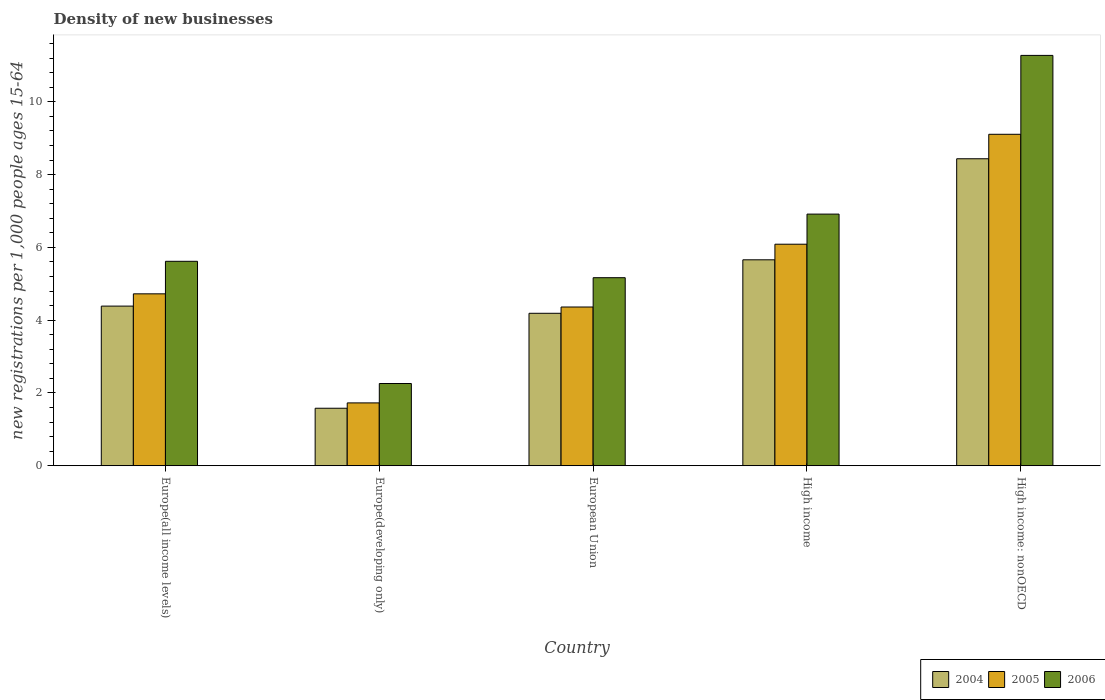How many different coloured bars are there?
Give a very brief answer. 3. Are the number of bars per tick equal to the number of legend labels?
Your response must be concise. Yes. What is the label of the 5th group of bars from the left?
Offer a very short reply. High income: nonOECD. In how many cases, is the number of bars for a given country not equal to the number of legend labels?
Provide a succinct answer. 0. What is the number of new registrations in 2006 in Europe(all income levels)?
Offer a terse response. 5.62. Across all countries, what is the maximum number of new registrations in 2006?
Offer a terse response. 11.28. Across all countries, what is the minimum number of new registrations in 2005?
Offer a terse response. 1.73. In which country was the number of new registrations in 2006 maximum?
Keep it short and to the point. High income: nonOECD. In which country was the number of new registrations in 2005 minimum?
Provide a succinct answer. Europe(developing only). What is the total number of new registrations in 2004 in the graph?
Your answer should be compact. 24.25. What is the difference between the number of new registrations in 2006 in Europe(all income levels) and that in High income: nonOECD?
Offer a terse response. -5.66. What is the difference between the number of new registrations in 2004 in High income: nonOECD and the number of new registrations in 2005 in European Union?
Keep it short and to the point. 4.07. What is the average number of new registrations in 2006 per country?
Offer a very short reply. 6.25. What is the difference between the number of new registrations of/in 2005 and number of new registrations of/in 2004 in European Union?
Your answer should be compact. 0.17. In how many countries, is the number of new registrations in 2005 greater than 3.2?
Provide a short and direct response. 4. What is the ratio of the number of new registrations in 2005 in Europe(all income levels) to that in High income?
Your answer should be very brief. 0.78. Is the number of new registrations in 2004 in European Union less than that in High income?
Provide a succinct answer. Yes. Is the difference between the number of new registrations in 2005 in Europe(all income levels) and Europe(developing only) greater than the difference between the number of new registrations in 2004 in Europe(all income levels) and Europe(developing only)?
Provide a short and direct response. Yes. What is the difference between the highest and the second highest number of new registrations in 2006?
Your answer should be compact. 5.66. What is the difference between the highest and the lowest number of new registrations in 2006?
Offer a terse response. 9.02. Is the sum of the number of new registrations in 2004 in Europe(developing only) and European Union greater than the maximum number of new registrations in 2005 across all countries?
Offer a very short reply. No. What does the 3rd bar from the left in High income represents?
Your answer should be compact. 2006. Is it the case that in every country, the sum of the number of new registrations in 2006 and number of new registrations in 2005 is greater than the number of new registrations in 2004?
Provide a short and direct response. Yes. How many bars are there?
Provide a succinct answer. 15. Are all the bars in the graph horizontal?
Your response must be concise. No. How many countries are there in the graph?
Make the answer very short. 5. Are the values on the major ticks of Y-axis written in scientific E-notation?
Give a very brief answer. No. Where does the legend appear in the graph?
Make the answer very short. Bottom right. How are the legend labels stacked?
Your response must be concise. Horizontal. What is the title of the graph?
Keep it short and to the point. Density of new businesses. What is the label or title of the Y-axis?
Your response must be concise. New registrations per 1,0 people ages 15-64. What is the new registrations per 1,000 people ages 15-64 in 2004 in Europe(all income levels)?
Offer a terse response. 4.39. What is the new registrations per 1,000 people ages 15-64 in 2005 in Europe(all income levels)?
Your answer should be very brief. 4.72. What is the new registrations per 1,000 people ages 15-64 of 2006 in Europe(all income levels)?
Make the answer very short. 5.62. What is the new registrations per 1,000 people ages 15-64 in 2004 in Europe(developing only)?
Provide a succinct answer. 1.58. What is the new registrations per 1,000 people ages 15-64 of 2005 in Europe(developing only)?
Ensure brevity in your answer.  1.73. What is the new registrations per 1,000 people ages 15-64 of 2006 in Europe(developing only)?
Offer a very short reply. 2.26. What is the new registrations per 1,000 people ages 15-64 in 2004 in European Union?
Keep it short and to the point. 4.19. What is the new registrations per 1,000 people ages 15-64 in 2005 in European Union?
Ensure brevity in your answer.  4.36. What is the new registrations per 1,000 people ages 15-64 in 2006 in European Union?
Give a very brief answer. 5.17. What is the new registrations per 1,000 people ages 15-64 in 2004 in High income?
Your answer should be compact. 5.66. What is the new registrations per 1,000 people ages 15-64 of 2005 in High income?
Make the answer very short. 6.09. What is the new registrations per 1,000 people ages 15-64 in 2006 in High income?
Your answer should be very brief. 6.91. What is the new registrations per 1,000 people ages 15-64 of 2004 in High income: nonOECD?
Give a very brief answer. 8.44. What is the new registrations per 1,000 people ages 15-64 of 2005 in High income: nonOECD?
Make the answer very short. 9.11. What is the new registrations per 1,000 people ages 15-64 in 2006 in High income: nonOECD?
Make the answer very short. 11.28. Across all countries, what is the maximum new registrations per 1,000 people ages 15-64 in 2004?
Provide a short and direct response. 8.44. Across all countries, what is the maximum new registrations per 1,000 people ages 15-64 in 2005?
Your response must be concise. 9.11. Across all countries, what is the maximum new registrations per 1,000 people ages 15-64 in 2006?
Offer a very short reply. 11.28. Across all countries, what is the minimum new registrations per 1,000 people ages 15-64 in 2004?
Ensure brevity in your answer.  1.58. Across all countries, what is the minimum new registrations per 1,000 people ages 15-64 in 2005?
Provide a succinct answer. 1.73. Across all countries, what is the minimum new registrations per 1,000 people ages 15-64 of 2006?
Give a very brief answer. 2.26. What is the total new registrations per 1,000 people ages 15-64 of 2004 in the graph?
Keep it short and to the point. 24.25. What is the total new registrations per 1,000 people ages 15-64 of 2005 in the graph?
Make the answer very short. 26.01. What is the total new registrations per 1,000 people ages 15-64 of 2006 in the graph?
Give a very brief answer. 31.24. What is the difference between the new registrations per 1,000 people ages 15-64 of 2004 in Europe(all income levels) and that in Europe(developing only)?
Provide a succinct answer. 2.81. What is the difference between the new registrations per 1,000 people ages 15-64 in 2005 in Europe(all income levels) and that in Europe(developing only)?
Make the answer very short. 3. What is the difference between the new registrations per 1,000 people ages 15-64 of 2006 in Europe(all income levels) and that in Europe(developing only)?
Keep it short and to the point. 3.36. What is the difference between the new registrations per 1,000 people ages 15-64 in 2004 in Europe(all income levels) and that in European Union?
Make the answer very short. 0.2. What is the difference between the new registrations per 1,000 people ages 15-64 of 2005 in Europe(all income levels) and that in European Union?
Provide a short and direct response. 0.36. What is the difference between the new registrations per 1,000 people ages 15-64 in 2006 in Europe(all income levels) and that in European Union?
Keep it short and to the point. 0.45. What is the difference between the new registrations per 1,000 people ages 15-64 of 2004 in Europe(all income levels) and that in High income?
Provide a short and direct response. -1.27. What is the difference between the new registrations per 1,000 people ages 15-64 of 2005 in Europe(all income levels) and that in High income?
Provide a succinct answer. -1.36. What is the difference between the new registrations per 1,000 people ages 15-64 of 2006 in Europe(all income levels) and that in High income?
Offer a terse response. -1.3. What is the difference between the new registrations per 1,000 people ages 15-64 of 2004 in Europe(all income levels) and that in High income: nonOECD?
Offer a very short reply. -4.05. What is the difference between the new registrations per 1,000 people ages 15-64 in 2005 in Europe(all income levels) and that in High income: nonOECD?
Offer a very short reply. -4.38. What is the difference between the new registrations per 1,000 people ages 15-64 in 2006 in Europe(all income levels) and that in High income: nonOECD?
Give a very brief answer. -5.66. What is the difference between the new registrations per 1,000 people ages 15-64 of 2004 in Europe(developing only) and that in European Union?
Your answer should be very brief. -2.61. What is the difference between the new registrations per 1,000 people ages 15-64 of 2005 in Europe(developing only) and that in European Union?
Give a very brief answer. -2.64. What is the difference between the new registrations per 1,000 people ages 15-64 in 2006 in Europe(developing only) and that in European Union?
Ensure brevity in your answer.  -2.91. What is the difference between the new registrations per 1,000 people ages 15-64 in 2004 in Europe(developing only) and that in High income?
Provide a succinct answer. -4.08. What is the difference between the new registrations per 1,000 people ages 15-64 in 2005 in Europe(developing only) and that in High income?
Offer a terse response. -4.36. What is the difference between the new registrations per 1,000 people ages 15-64 in 2006 in Europe(developing only) and that in High income?
Your response must be concise. -4.66. What is the difference between the new registrations per 1,000 people ages 15-64 of 2004 in Europe(developing only) and that in High income: nonOECD?
Make the answer very short. -6.86. What is the difference between the new registrations per 1,000 people ages 15-64 of 2005 in Europe(developing only) and that in High income: nonOECD?
Your answer should be very brief. -7.38. What is the difference between the new registrations per 1,000 people ages 15-64 of 2006 in Europe(developing only) and that in High income: nonOECD?
Offer a terse response. -9.02. What is the difference between the new registrations per 1,000 people ages 15-64 in 2004 in European Union and that in High income?
Offer a very short reply. -1.47. What is the difference between the new registrations per 1,000 people ages 15-64 in 2005 in European Union and that in High income?
Provide a short and direct response. -1.73. What is the difference between the new registrations per 1,000 people ages 15-64 in 2006 in European Union and that in High income?
Your answer should be very brief. -1.75. What is the difference between the new registrations per 1,000 people ages 15-64 in 2004 in European Union and that in High income: nonOECD?
Keep it short and to the point. -4.25. What is the difference between the new registrations per 1,000 people ages 15-64 of 2005 in European Union and that in High income: nonOECD?
Give a very brief answer. -4.75. What is the difference between the new registrations per 1,000 people ages 15-64 in 2006 in European Union and that in High income: nonOECD?
Ensure brevity in your answer.  -6.11. What is the difference between the new registrations per 1,000 people ages 15-64 of 2004 in High income and that in High income: nonOECD?
Provide a short and direct response. -2.78. What is the difference between the new registrations per 1,000 people ages 15-64 in 2005 in High income and that in High income: nonOECD?
Your answer should be very brief. -3.02. What is the difference between the new registrations per 1,000 people ages 15-64 in 2006 in High income and that in High income: nonOECD?
Offer a terse response. -4.36. What is the difference between the new registrations per 1,000 people ages 15-64 of 2004 in Europe(all income levels) and the new registrations per 1,000 people ages 15-64 of 2005 in Europe(developing only)?
Your answer should be very brief. 2.66. What is the difference between the new registrations per 1,000 people ages 15-64 of 2004 in Europe(all income levels) and the new registrations per 1,000 people ages 15-64 of 2006 in Europe(developing only)?
Provide a short and direct response. 2.13. What is the difference between the new registrations per 1,000 people ages 15-64 in 2005 in Europe(all income levels) and the new registrations per 1,000 people ages 15-64 in 2006 in Europe(developing only)?
Give a very brief answer. 2.46. What is the difference between the new registrations per 1,000 people ages 15-64 in 2004 in Europe(all income levels) and the new registrations per 1,000 people ages 15-64 in 2005 in European Union?
Provide a succinct answer. 0.02. What is the difference between the new registrations per 1,000 people ages 15-64 in 2004 in Europe(all income levels) and the new registrations per 1,000 people ages 15-64 in 2006 in European Union?
Provide a succinct answer. -0.78. What is the difference between the new registrations per 1,000 people ages 15-64 in 2005 in Europe(all income levels) and the new registrations per 1,000 people ages 15-64 in 2006 in European Union?
Keep it short and to the point. -0.44. What is the difference between the new registrations per 1,000 people ages 15-64 in 2004 in Europe(all income levels) and the new registrations per 1,000 people ages 15-64 in 2005 in High income?
Your response must be concise. -1.7. What is the difference between the new registrations per 1,000 people ages 15-64 in 2004 in Europe(all income levels) and the new registrations per 1,000 people ages 15-64 in 2006 in High income?
Keep it short and to the point. -2.53. What is the difference between the new registrations per 1,000 people ages 15-64 in 2005 in Europe(all income levels) and the new registrations per 1,000 people ages 15-64 in 2006 in High income?
Offer a very short reply. -2.19. What is the difference between the new registrations per 1,000 people ages 15-64 in 2004 in Europe(all income levels) and the new registrations per 1,000 people ages 15-64 in 2005 in High income: nonOECD?
Offer a very short reply. -4.72. What is the difference between the new registrations per 1,000 people ages 15-64 in 2004 in Europe(all income levels) and the new registrations per 1,000 people ages 15-64 in 2006 in High income: nonOECD?
Keep it short and to the point. -6.89. What is the difference between the new registrations per 1,000 people ages 15-64 in 2005 in Europe(all income levels) and the new registrations per 1,000 people ages 15-64 in 2006 in High income: nonOECD?
Your answer should be very brief. -6.55. What is the difference between the new registrations per 1,000 people ages 15-64 of 2004 in Europe(developing only) and the new registrations per 1,000 people ages 15-64 of 2005 in European Union?
Offer a terse response. -2.78. What is the difference between the new registrations per 1,000 people ages 15-64 in 2004 in Europe(developing only) and the new registrations per 1,000 people ages 15-64 in 2006 in European Union?
Provide a succinct answer. -3.59. What is the difference between the new registrations per 1,000 people ages 15-64 of 2005 in Europe(developing only) and the new registrations per 1,000 people ages 15-64 of 2006 in European Union?
Provide a short and direct response. -3.44. What is the difference between the new registrations per 1,000 people ages 15-64 of 2004 in Europe(developing only) and the new registrations per 1,000 people ages 15-64 of 2005 in High income?
Ensure brevity in your answer.  -4.51. What is the difference between the new registrations per 1,000 people ages 15-64 in 2004 in Europe(developing only) and the new registrations per 1,000 people ages 15-64 in 2006 in High income?
Offer a terse response. -5.33. What is the difference between the new registrations per 1,000 people ages 15-64 of 2005 in Europe(developing only) and the new registrations per 1,000 people ages 15-64 of 2006 in High income?
Provide a short and direct response. -5.19. What is the difference between the new registrations per 1,000 people ages 15-64 in 2004 in Europe(developing only) and the new registrations per 1,000 people ages 15-64 in 2005 in High income: nonOECD?
Provide a succinct answer. -7.53. What is the difference between the new registrations per 1,000 people ages 15-64 of 2004 in Europe(developing only) and the new registrations per 1,000 people ages 15-64 of 2006 in High income: nonOECD?
Ensure brevity in your answer.  -9.7. What is the difference between the new registrations per 1,000 people ages 15-64 of 2005 in Europe(developing only) and the new registrations per 1,000 people ages 15-64 of 2006 in High income: nonOECD?
Your answer should be very brief. -9.55. What is the difference between the new registrations per 1,000 people ages 15-64 of 2004 in European Union and the new registrations per 1,000 people ages 15-64 of 2005 in High income?
Your answer should be compact. -1.9. What is the difference between the new registrations per 1,000 people ages 15-64 in 2004 in European Union and the new registrations per 1,000 people ages 15-64 in 2006 in High income?
Offer a very short reply. -2.73. What is the difference between the new registrations per 1,000 people ages 15-64 in 2005 in European Union and the new registrations per 1,000 people ages 15-64 in 2006 in High income?
Offer a terse response. -2.55. What is the difference between the new registrations per 1,000 people ages 15-64 in 2004 in European Union and the new registrations per 1,000 people ages 15-64 in 2005 in High income: nonOECD?
Your answer should be very brief. -4.92. What is the difference between the new registrations per 1,000 people ages 15-64 of 2004 in European Union and the new registrations per 1,000 people ages 15-64 of 2006 in High income: nonOECD?
Make the answer very short. -7.09. What is the difference between the new registrations per 1,000 people ages 15-64 of 2005 in European Union and the new registrations per 1,000 people ages 15-64 of 2006 in High income: nonOECD?
Make the answer very short. -6.91. What is the difference between the new registrations per 1,000 people ages 15-64 in 2004 in High income and the new registrations per 1,000 people ages 15-64 in 2005 in High income: nonOECD?
Offer a terse response. -3.45. What is the difference between the new registrations per 1,000 people ages 15-64 in 2004 in High income and the new registrations per 1,000 people ages 15-64 in 2006 in High income: nonOECD?
Provide a succinct answer. -5.62. What is the difference between the new registrations per 1,000 people ages 15-64 of 2005 in High income and the new registrations per 1,000 people ages 15-64 of 2006 in High income: nonOECD?
Your response must be concise. -5.19. What is the average new registrations per 1,000 people ages 15-64 in 2004 per country?
Keep it short and to the point. 4.85. What is the average new registrations per 1,000 people ages 15-64 of 2005 per country?
Give a very brief answer. 5.2. What is the average new registrations per 1,000 people ages 15-64 in 2006 per country?
Provide a short and direct response. 6.25. What is the difference between the new registrations per 1,000 people ages 15-64 of 2004 and new registrations per 1,000 people ages 15-64 of 2005 in Europe(all income levels)?
Your answer should be compact. -0.34. What is the difference between the new registrations per 1,000 people ages 15-64 in 2004 and new registrations per 1,000 people ages 15-64 in 2006 in Europe(all income levels)?
Offer a very short reply. -1.23. What is the difference between the new registrations per 1,000 people ages 15-64 of 2005 and new registrations per 1,000 people ages 15-64 of 2006 in Europe(all income levels)?
Your answer should be very brief. -0.89. What is the difference between the new registrations per 1,000 people ages 15-64 of 2004 and new registrations per 1,000 people ages 15-64 of 2005 in Europe(developing only)?
Your answer should be compact. -0.15. What is the difference between the new registrations per 1,000 people ages 15-64 of 2004 and new registrations per 1,000 people ages 15-64 of 2006 in Europe(developing only)?
Ensure brevity in your answer.  -0.68. What is the difference between the new registrations per 1,000 people ages 15-64 of 2005 and new registrations per 1,000 people ages 15-64 of 2006 in Europe(developing only)?
Your answer should be very brief. -0.53. What is the difference between the new registrations per 1,000 people ages 15-64 of 2004 and new registrations per 1,000 people ages 15-64 of 2005 in European Union?
Your answer should be compact. -0.17. What is the difference between the new registrations per 1,000 people ages 15-64 of 2004 and new registrations per 1,000 people ages 15-64 of 2006 in European Union?
Provide a succinct answer. -0.98. What is the difference between the new registrations per 1,000 people ages 15-64 in 2005 and new registrations per 1,000 people ages 15-64 in 2006 in European Union?
Your answer should be very brief. -0.81. What is the difference between the new registrations per 1,000 people ages 15-64 of 2004 and new registrations per 1,000 people ages 15-64 of 2005 in High income?
Provide a succinct answer. -0.43. What is the difference between the new registrations per 1,000 people ages 15-64 of 2004 and new registrations per 1,000 people ages 15-64 of 2006 in High income?
Offer a terse response. -1.26. What is the difference between the new registrations per 1,000 people ages 15-64 in 2005 and new registrations per 1,000 people ages 15-64 in 2006 in High income?
Your answer should be compact. -0.83. What is the difference between the new registrations per 1,000 people ages 15-64 of 2004 and new registrations per 1,000 people ages 15-64 of 2005 in High income: nonOECD?
Offer a very short reply. -0.67. What is the difference between the new registrations per 1,000 people ages 15-64 of 2004 and new registrations per 1,000 people ages 15-64 of 2006 in High income: nonOECD?
Provide a short and direct response. -2.84. What is the difference between the new registrations per 1,000 people ages 15-64 in 2005 and new registrations per 1,000 people ages 15-64 in 2006 in High income: nonOECD?
Your response must be concise. -2.17. What is the ratio of the new registrations per 1,000 people ages 15-64 of 2004 in Europe(all income levels) to that in Europe(developing only)?
Provide a succinct answer. 2.78. What is the ratio of the new registrations per 1,000 people ages 15-64 in 2005 in Europe(all income levels) to that in Europe(developing only)?
Ensure brevity in your answer.  2.74. What is the ratio of the new registrations per 1,000 people ages 15-64 in 2006 in Europe(all income levels) to that in Europe(developing only)?
Offer a very short reply. 2.49. What is the ratio of the new registrations per 1,000 people ages 15-64 of 2004 in Europe(all income levels) to that in European Union?
Ensure brevity in your answer.  1.05. What is the ratio of the new registrations per 1,000 people ages 15-64 of 2005 in Europe(all income levels) to that in European Union?
Your answer should be compact. 1.08. What is the ratio of the new registrations per 1,000 people ages 15-64 of 2006 in Europe(all income levels) to that in European Union?
Keep it short and to the point. 1.09. What is the ratio of the new registrations per 1,000 people ages 15-64 in 2004 in Europe(all income levels) to that in High income?
Give a very brief answer. 0.78. What is the ratio of the new registrations per 1,000 people ages 15-64 of 2005 in Europe(all income levels) to that in High income?
Ensure brevity in your answer.  0.78. What is the ratio of the new registrations per 1,000 people ages 15-64 of 2006 in Europe(all income levels) to that in High income?
Give a very brief answer. 0.81. What is the ratio of the new registrations per 1,000 people ages 15-64 of 2004 in Europe(all income levels) to that in High income: nonOECD?
Your answer should be very brief. 0.52. What is the ratio of the new registrations per 1,000 people ages 15-64 in 2005 in Europe(all income levels) to that in High income: nonOECD?
Make the answer very short. 0.52. What is the ratio of the new registrations per 1,000 people ages 15-64 in 2006 in Europe(all income levels) to that in High income: nonOECD?
Give a very brief answer. 0.5. What is the ratio of the new registrations per 1,000 people ages 15-64 in 2004 in Europe(developing only) to that in European Union?
Give a very brief answer. 0.38. What is the ratio of the new registrations per 1,000 people ages 15-64 in 2005 in Europe(developing only) to that in European Union?
Offer a very short reply. 0.4. What is the ratio of the new registrations per 1,000 people ages 15-64 in 2006 in Europe(developing only) to that in European Union?
Your answer should be very brief. 0.44. What is the ratio of the new registrations per 1,000 people ages 15-64 in 2004 in Europe(developing only) to that in High income?
Your answer should be very brief. 0.28. What is the ratio of the new registrations per 1,000 people ages 15-64 of 2005 in Europe(developing only) to that in High income?
Offer a terse response. 0.28. What is the ratio of the new registrations per 1,000 people ages 15-64 in 2006 in Europe(developing only) to that in High income?
Provide a short and direct response. 0.33. What is the ratio of the new registrations per 1,000 people ages 15-64 in 2004 in Europe(developing only) to that in High income: nonOECD?
Provide a short and direct response. 0.19. What is the ratio of the new registrations per 1,000 people ages 15-64 of 2005 in Europe(developing only) to that in High income: nonOECD?
Offer a very short reply. 0.19. What is the ratio of the new registrations per 1,000 people ages 15-64 of 2006 in Europe(developing only) to that in High income: nonOECD?
Your response must be concise. 0.2. What is the ratio of the new registrations per 1,000 people ages 15-64 in 2004 in European Union to that in High income?
Provide a succinct answer. 0.74. What is the ratio of the new registrations per 1,000 people ages 15-64 in 2005 in European Union to that in High income?
Give a very brief answer. 0.72. What is the ratio of the new registrations per 1,000 people ages 15-64 in 2006 in European Union to that in High income?
Your answer should be compact. 0.75. What is the ratio of the new registrations per 1,000 people ages 15-64 of 2004 in European Union to that in High income: nonOECD?
Your response must be concise. 0.5. What is the ratio of the new registrations per 1,000 people ages 15-64 of 2005 in European Union to that in High income: nonOECD?
Your answer should be compact. 0.48. What is the ratio of the new registrations per 1,000 people ages 15-64 in 2006 in European Union to that in High income: nonOECD?
Your answer should be very brief. 0.46. What is the ratio of the new registrations per 1,000 people ages 15-64 in 2004 in High income to that in High income: nonOECD?
Offer a very short reply. 0.67. What is the ratio of the new registrations per 1,000 people ages 15-64 of 2005 in High income to that in High income: nonOECD?
Your answer should be compact. 0.67. What is the ratio of the new registrations per 1,000 people ages 15-64 in 2006 in High income to that in High income: nonOECD?
Provide a short and direct response. 0.61. What is the difference between the highest and the second highest new registrations per 1,000 people ages 15-64 of 2004?
Offer a terse response. 2.78. What is the difference between the highest and the second highest new registrations per 1,000 people ages 15-64 of 2005?
Ensure brevity in your answer.  3.02. What is the difference between the highest and the second highest new registrations per 1,000 people ages 15-64 in 2006?
Offer a very short reply. 4.36. What is the difference between the highest and the lowest new registrations per 1,000 people ages 15-64 of 2004?
Your response must be concise. 6.86. What is the difference between the highest and the lowest new registrations per 1,000 people ages 15-64 of 2005?
Offer a terse response. 7.38. What is the difference between the highest and the lowest new registrations per 1,000 people ages 15-64 of 2006?
Keep it short and to the point. 9.02. 